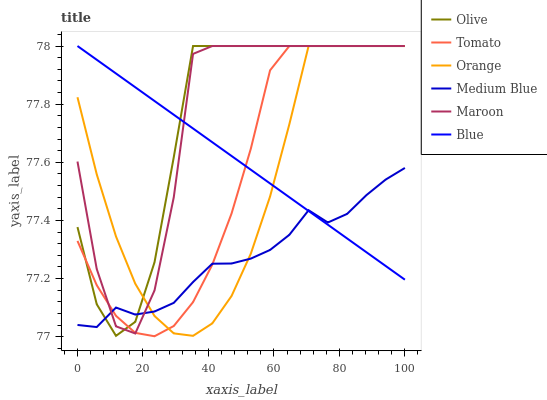Does Medium Blue have the minimum area under the curve?
Answer yes or no. Yes. Does Olive have the maximum area under the curve?
Answer yes or no. Yes. Does Blue have the minimum area under the curve?
Answer yes or no. No. Does Blue have the maximum area under the curve?
Answer yes or no. No. Is Blue the smoothest?
Answer yes or no. Yes. Is Maroon the roughest?
Answer yes or no. Yes. Is Medium Blue the smoothest?
Answer yes or no. No. Is Medium Blue the roughest?
Answer yes or no. No. Does Tomato have the lowest value?
Answer yes or no. Yes. Does Medium Blue have the lowest value?
Answer yes or no. No. Does Olive have the highest value?
Answer yes or no. Yes. Does Medium Blue have the highest value?
Answer yes or no. No. Does Tomato intersect Orange?
Answer yes or no. Yes. Is Tomato less than Orange?
Answer yes or no. No. Is Tomato greater than Orange?
Answer yes or no. No. 